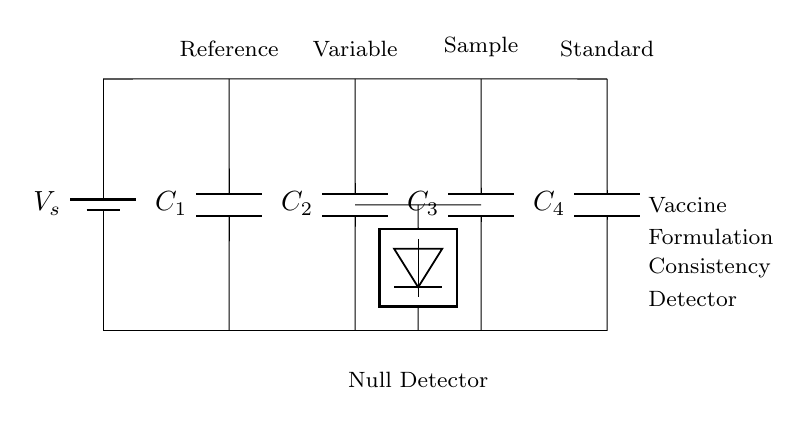What is the voltage source labeled as in this circuit? The voltage source is labeled as \( V_s \), which indicates the supply voltage for the entire circuit.
Answer: V_s What are the components of the bridge circuit? The components include four capacitors labeled \( C_1, C_2, C_3, C_4 \) and a null detector, which is used to measure the balance in the circuit.
Answer: Four capacitors and a null detector What is the function of the detector in this circuit? The detector measures potential differences or signal levels across the components, indicating if there is a balance or difference due to the formulation in the sample capacitor.
Answer: To measure balance Which capacitor is designated as the variable capacitor? The variable capacitor is labeled as \( C_2 \), indicating that it can be adjusted to achieve balance in the circuit.
Answer: C_2 If the sample capacitor \( C_3 \) is changed, how might this affect the balance of the bridge? Changing \( C_3 \) would alter the capacitance in the circuit, possibly causing an imbalance that the detector will measure, indicating the need for adjustment in the other capacitors to restore balance.
Answer: It may cause an imbalance Why is this circuit referred to as a "bridge" circuit? This circuit is called a bridge circuit because it consists of two parallel branches that create a "bridge" structure, allowing for comparison between a known reference and a sample, thereby detecting changes in consistency.
Answer: Because it compares reference and sample 